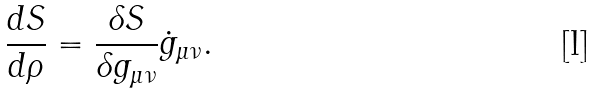Convert formula to latex. <formula><loc_0><loc_0><loc_500><loc_500>\frac { d S } { d \rho } = \frac { \delta S } { \delta g _ { \mu \nu } } \dot { g } _ { \mu \nu } .</formula> 